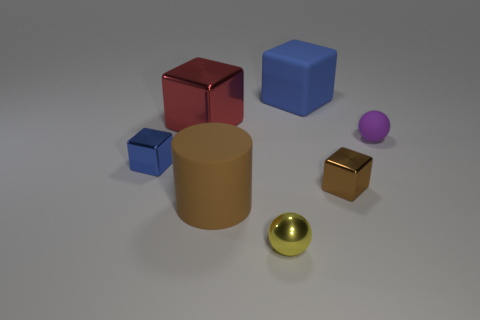Subtract all blue cubes. How many were subtracted if there are1blue cubes left? 1 Subtract all tiny brown metallic blocks. How many blocks are left? 3 Subtract all brown balls. How many blue blocks are left? 2 Subtract all brown blocks. How many blocks are left? 3 Add 1 large yellow rubber spheres. How many objects exist? 8 Subtract 1 blocks. How many blocks are left? 3 Subtract all cyan blocks. Subtract all gray balls. How many blocks are left? 4 Subtract all cylinders. How many objects are left? 6 Subtract all red shiny things. Subtract all metallic balls. How many objects are left? 5 Add 4 small purple rubber things. How many small purple rubber things are left? 5 